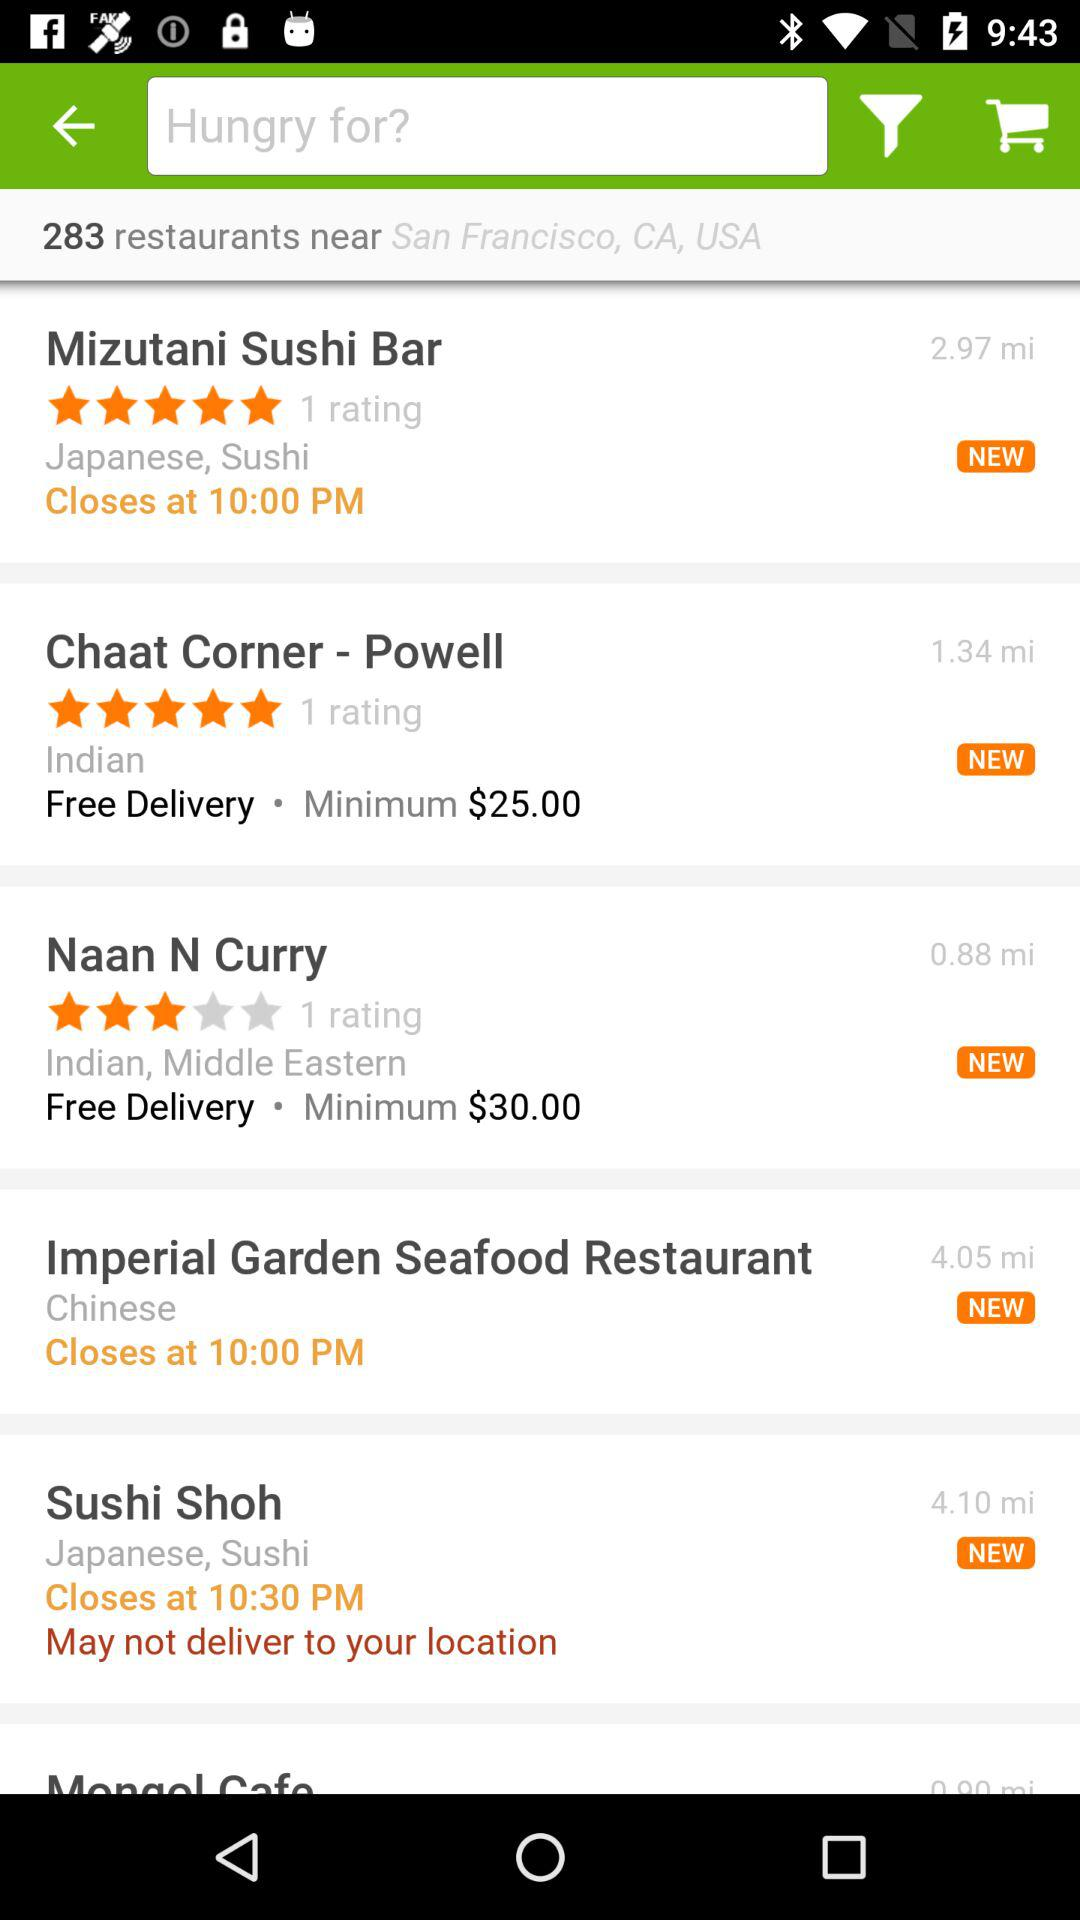What is the rating of "Mizutani Sushi Bar"? The rating is 5 stars. 